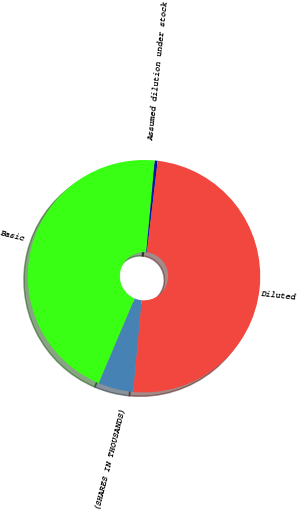Convert chart. <chart><loc_0><loc_0><loc_500><loc_500><pie_chart><fcel>(SHARES IN THOUSANDS)<fcel>Basic<fcel>Assumed dilution under stock<fcel>Diluted<nl><fcel>4.91%<fcel>45.09%<fcel>0.4%<fcel>49.6%<nl></chart> 